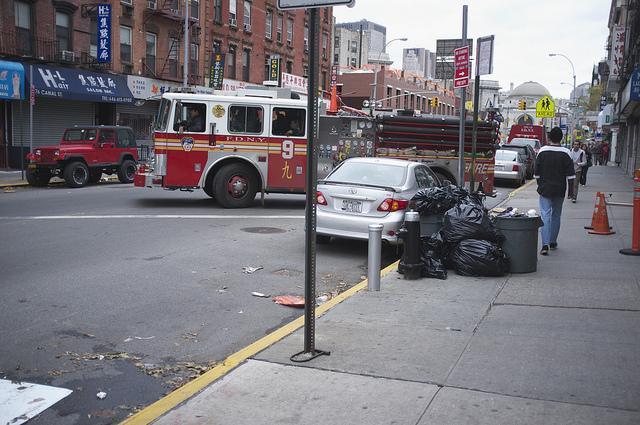For which city does this fire truck perform work?
Make your selection from the four choices given to correctly answer the question.
Options: New york, kentucky, arkansas, new jersey. New york. 